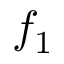Convert formula to latex. <formula><loc_0><loc_0><loc_500><loc_500>f _ { 1 }</formula> 